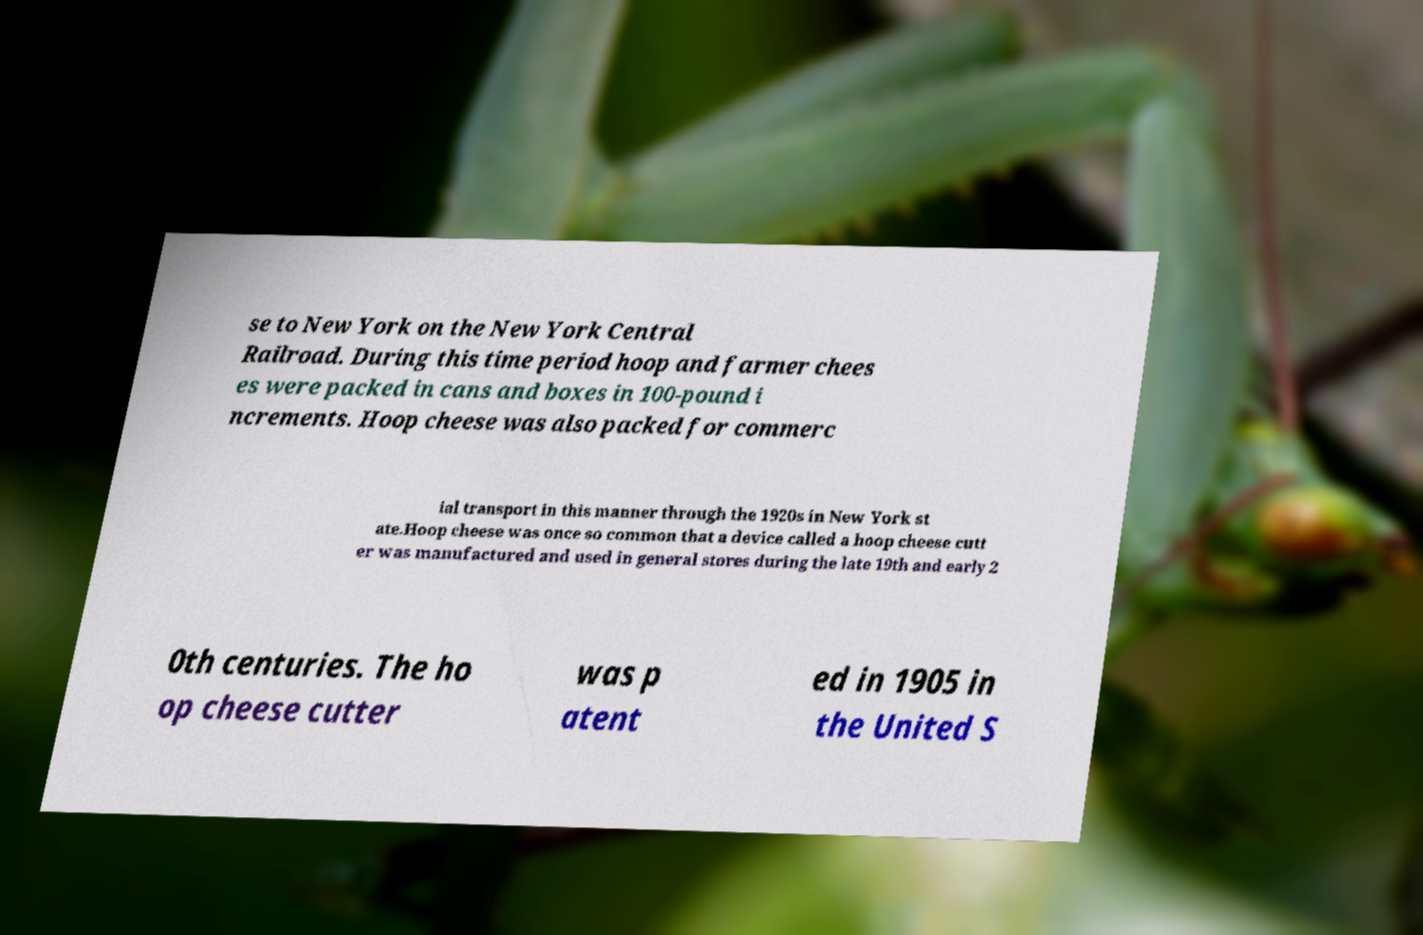Could you extract and type out the text from this image? se to New York on the New York Central Railroad. During this time period hoop and farmer chees es were packed in cans and boxes in 100-pound i ncrements. Hoop cheese was also packed for commerc ial transport in this manner through the 1920s in New York st ate.Hoop cheese was once so common that a device called a hoop cheese cutt er was manufactured and used in general stores during the late 19th and early 2 0th centuries. The ho op cheese cutter was p atent ed in 1905 in the United S 